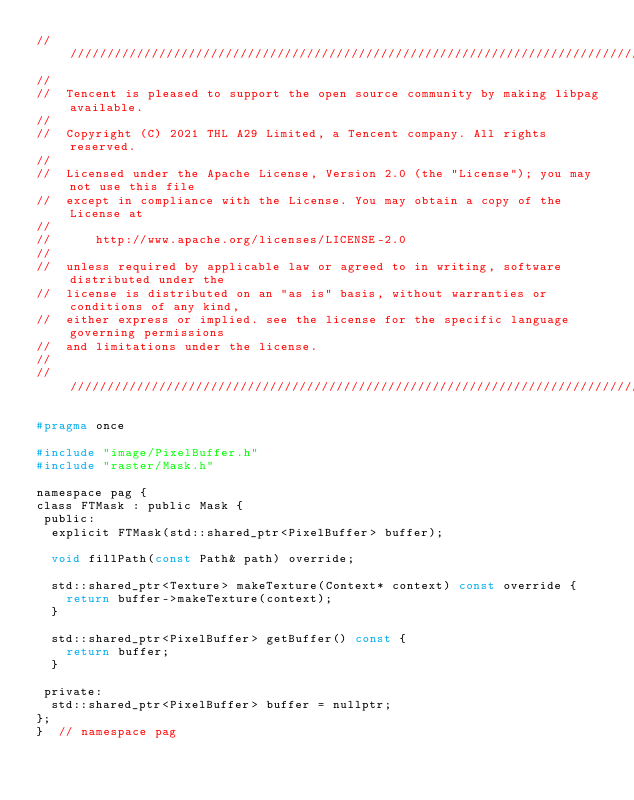<code> <loc_0><loc_0><loc_500><loc_500><_C_>/////////////////////////////////////////////////////////////////////////////////////////////////
//
//  Tencent is pleased to support the open source community by making libpag available.
//
//  Copyright (C) 2021 THL A29 Limited, a Tencent company. All rights reserved.
//
//  Licensed under the Apache License, Version 2.0 (the "License"); you may not use this file
//  except in compliance with the License. You may obtain a copy of the License at
//
//      http://www.apache.org/licenses/LICENSE-2.0
//
//  unless required by applicable law or agreed to in writing, software distributed under the
//  license is distributed on an "as is" basis, without warranties or conditions of any kind,
//  either express or implied. see the license for the specific language governing permissions
//  and limitations under the license.
//
/////////////////////////////////////////////////////////////////////////////////////////////////

#pragma once

#include "image/PixelBuffer.h"
#include "raster/Mask.h"

namespace pag {
class FTMask : public Mask {
 public:
  explicit FTMask(std::shared_ptr<PixelBuffer> buffer);

  void fillPath(const Path& path) override;

  std::shared_ptr<Texture> makeTexture(Context* context) const override {
    return buffer->makeTexture(context);
  }

  std::shared_ptr<PixelBuffer> getBuffer() const {
    return buffer;
  }

 private:
  std::shared_ptr<PixelBuffer> buffer = nullptr;
};
}  // namespace pag
</code> 